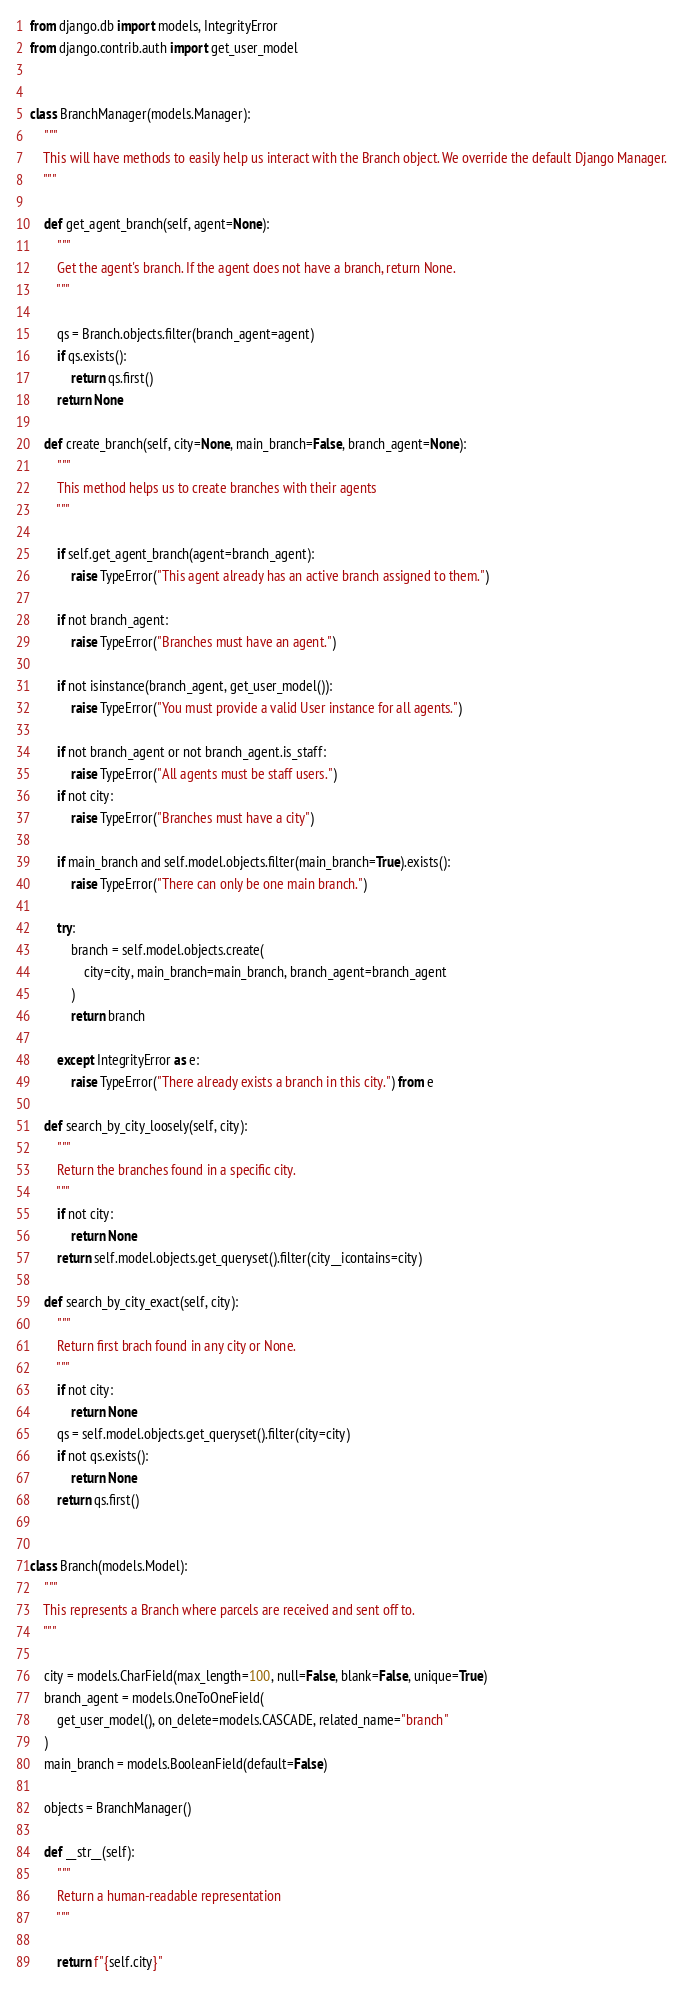Convert code to text. <code><loc_0><loc_0><loc_500><loc_500><_Python_>from django.db import models, IntegrityError
from django.contrib.auth import get_user_model


class BranchManager(models.Manager):
    """
    This will have methods to easily help us interact with the Branch object. We override the default Django Manager.
    """

    def get_agent_branch(self, agent=None):
        """
        Get the agent's branch. If the agent does not have a branch, return None.
        """

        qs = Branch.objects.filter(branch_agent=agent)
        if qs.exists():
            return qs.first()
        return None

    def create_branch(self, city=None, main_branch=False, branch_agent=None):
        """
        This method helps us to create branches with their agents
        """

        if self.get_agent_branch(agent=branch_agent):
            raise TypeError("This agent already has an active branch assigned to them.")

        if not branch_agent:
            raise TypeError("Branches must have an agent.")

        if not isinstance(branch_agent, get_user_model()):
            raise TypeError("You must provide a valid User instance for all agents.")

        if not branch_agent or not branch_agent.is_staff:
            raise TypeError("All agents must be staff users.")
        if not city:
            raise TypeError("Branches must have a city")

        if main_branch and self.model.objects.filter(main_branch=True).exists():
            raise TypeError("There can only be one main branch.")

        try:
            branch = self.model.objects.create(
                city=city, main_branch=main_branch, branch_agent=branch_agent
            )
            return branch

        except IntegrityError as e:
            raise TypeError("There already exists a branch in this city.") from e

    def search_by_city_loosely(self, city):
        """
        Return the branches found in a specific city.
        """
        if not city:
            return None
        return self.model.objects.get_queryset().filter(city__icontains=city)

    def search_by_city_exact(self, city):
        """
        Return first brach found in any city or None.
        """
        if not city:
            return None
        qs = self.model.objects.get_queryset().filter(city=city)
        if not qs.exists():
            return None
        return qs.first()


class Branch(models.Model):
    """
    This represents a Branch where parcels are received and sent off to.
    """

    city = models.CharField(max_length=100, null=False, blank=False, unique=True)
    branch_agent = models.OneToOneField(
        get_user_model(), on_delete=models.CASCADE, related_name="branch"
    )
    main_branch = models.BooleanField(default=False)

    objects = BranchManager()

    def __str__(self):
        """
        Return a human-readable representation
        """

        return f"{self.city}"
</code> 